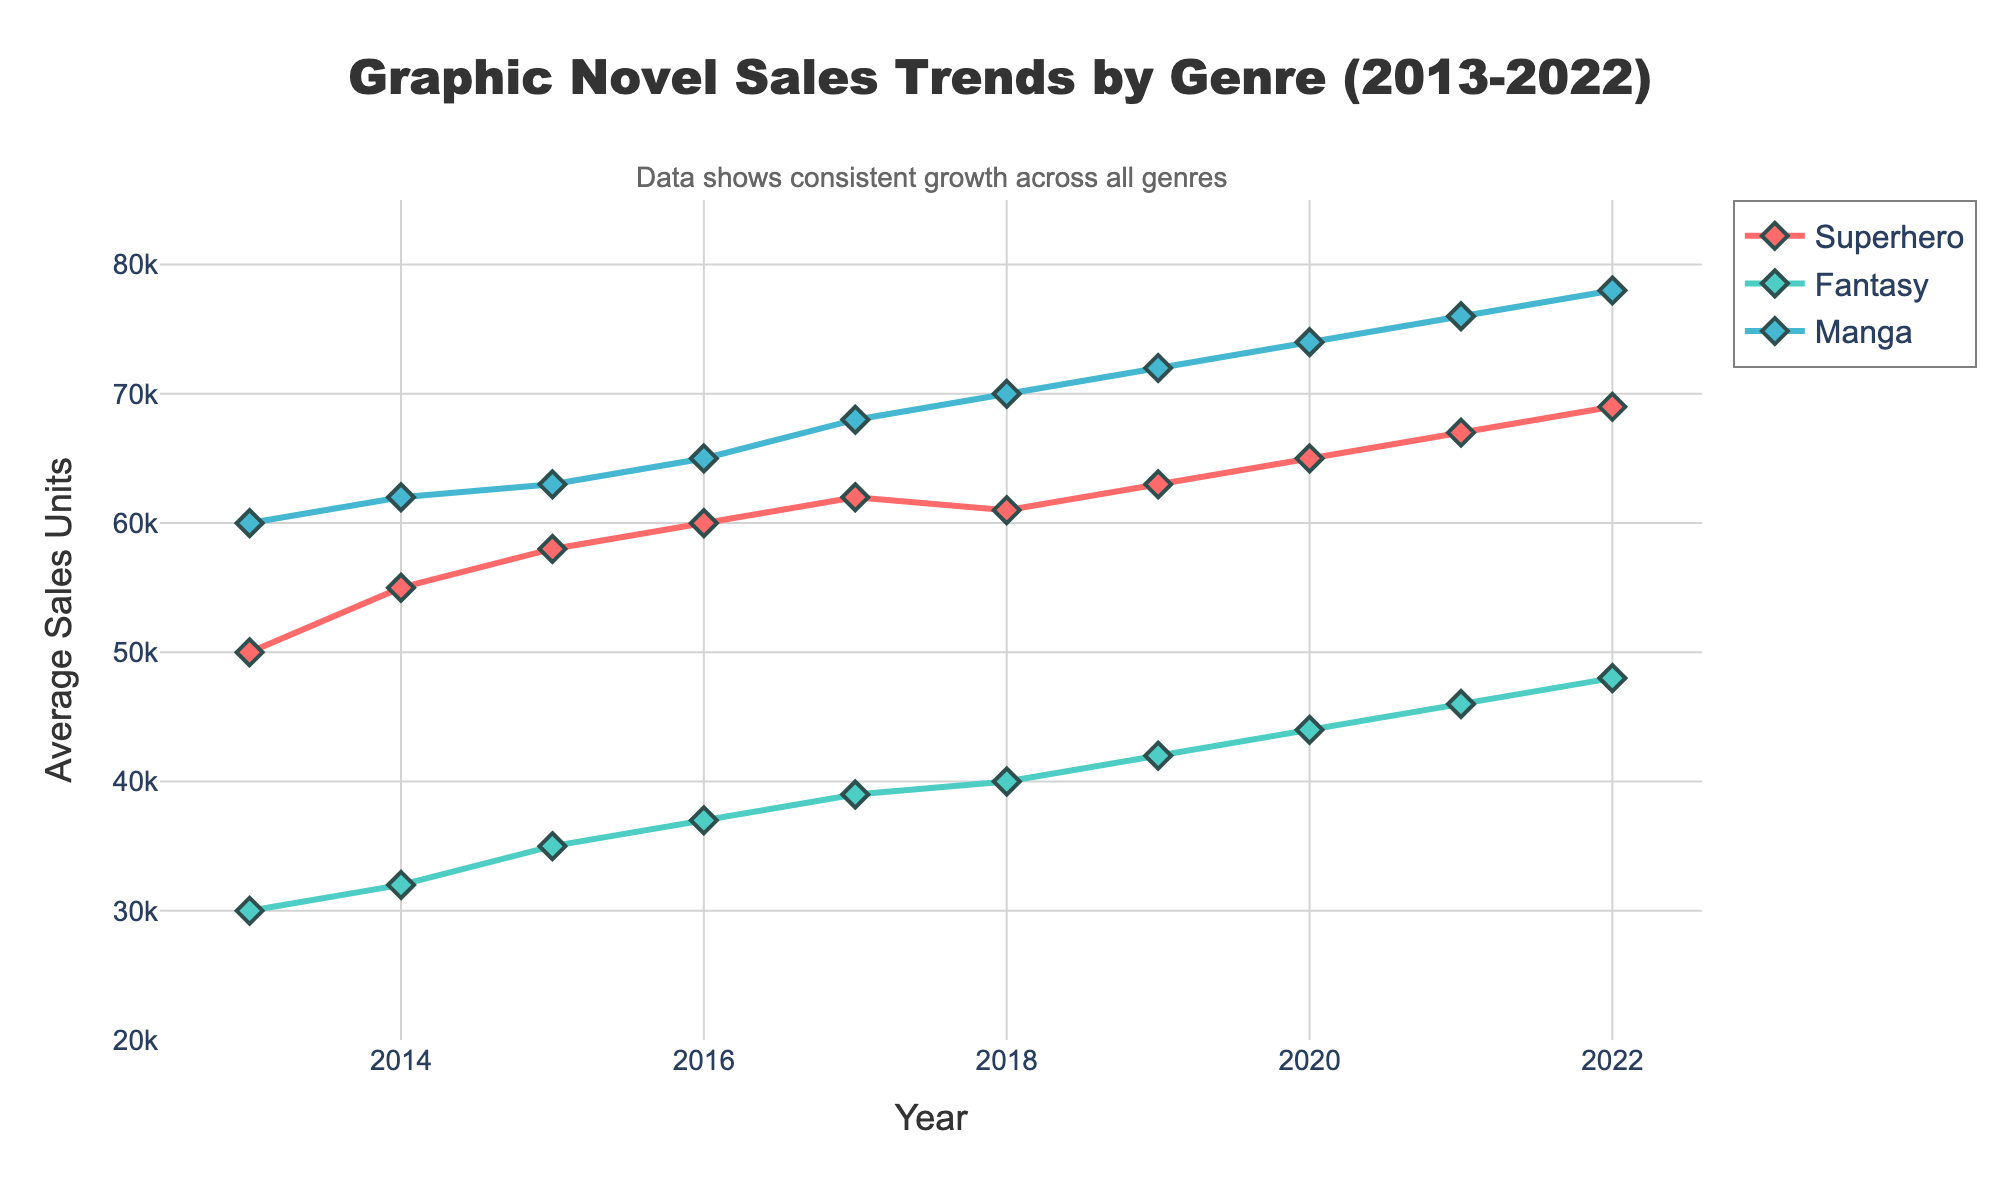what is the title of the figure? The title is displayed at the top of the figure. It reads "Graphic Novel Sales Trends by Genre (2013-2022)"
Answer: Graphic Novel Sales Trends by Genre (2013-2022) What is the range of the y-axis? The range of the y-axis is visible from the labels, showing from 20,000 to 85,000 average sales units.
Answer: 20,000 to 85,000 Which genre has the highest sales in 2013? To determine the highest sales in 2013, compare the y-values of the genres for that year. Manga has the highest value at 60,000.
Answer: Manga How did the Fantasy genre sales change from 2013 to 2022? Observe the y-values for Fantasy in 2013 and 2022. In 2013, sales were 30,000; in 2022, they were 48,000. Calculating the difference, the sales increased by 18,000 over the period.
Answer: Increased by 18,000 Which genre shows the most consistent growth over the decade? Consistent growth can be determined by a steady, upward trend over the years. All genres show growth, but Manga has the most uniform increase without any significant dips.
Answer: Manga In which year did the Superhero genre surpass 60,000 sales units for the first time? Look at the Superhero sales line and identify the first year it crosses the 60,000 sales units threshold. This occurred in 2016.
Answer: 2016 What was the average sales units for the Fantasy genre in 2018? Locate the data point for the Fantasy genre in 2018 and read the y-value. The average sales units were 40,000.
Answer: 40,000 Compare the sales units of Superhero and Fantasy genres in 2020. Which one had more sales? Examine the y-values for Superhero and Fantasy in 2020. Superhero had 65,000 sales units, while Fantasy had 44,000 sales units. Superhero had more sales.
Answer: Superhero What is the overall trend in sales for each genre from 2013 to 2022? Look at each genre's sales lines from 2013 to 2022 to determine the trend. All genres show an overall upward trend in sales.
Answer: Upward trend for all genres How much did Manga sales increase from 2017 to 2020? Compare the Manga sales units in 2017 (68,000) and 2020 (74,000). The increase is 74,000 - 68,000 = 6,000.
Answer: 6,000 